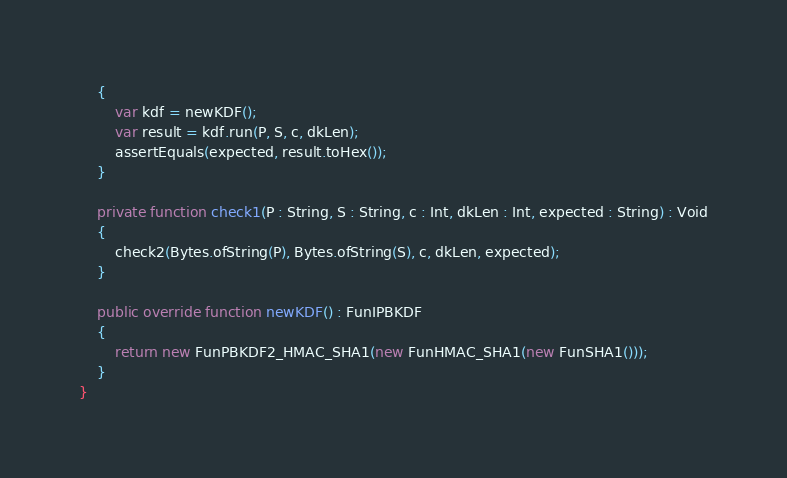Convert code to text. <code><loc_0><loc_0><loc_500><loc_500><_Haxe_>	{
		var kdf = newKDF();
		var result = kdf.run(P, S, c, dkLen);
		assertEquals(expected, result.toHex());
	}

	private function check1(P : String, S : String, c : Int, dkLen : Int, expected : String) : Void
	{
		check2(Bytes.ofString(P), Bytes.ofString(S), c, dkLen, expected);
	}

	public override function newKDF() : FunIPBKDF
	{
		return new FunPBKDF2_HMAC_SHA1(new FunHMAC_SHA1(new FunSHA1()));
	}
}
</code> 